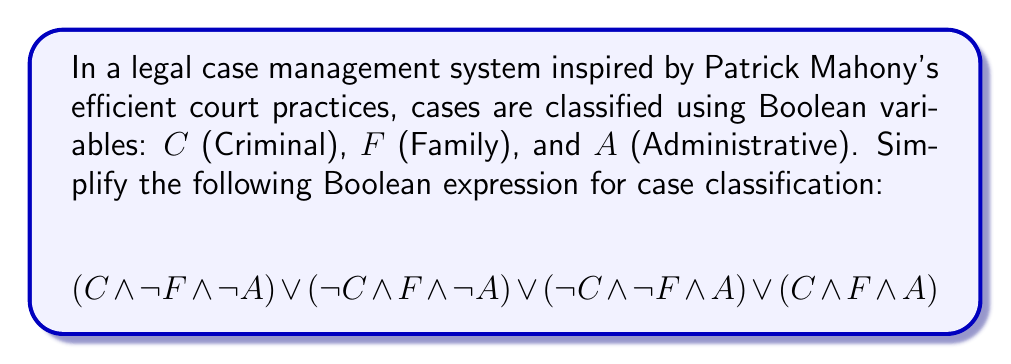Teach me how to tackle this problem. Let's simplify this Boolean expression step-by-step:

1) First, observe that the expression represents four mutually exclusive cases:
   - Criminal cases (not Family, not Administrative)
   - Family cases (not Criminal, not Administrative)
   - Administrative cases (not Criminal, not Family)
   - Cases that are simultaneously Criminal, Family, and Administrative

2) We can use the distributive law to factor out common terms:

   $$(C \land \lnot F \land \lnot A) \lor (\lnot C \land F \land \lnot A) \lor (\lnot C \land \lnot F \land A) \lor (C \land F \land A)$$
   $$= (\lnot A \land ((C \land \lnot F) \lor (\lnot C \land F))) \lor (A \land ((\lnot C \land \lnot F) \lor (C \land F)))$$

3) The terms $(C \land \lnot F) \lor (\lnot C \land F)$ and $(\lnot C \land \lnot F) \lor (C \land F)$ are both equivalent to the exclusive OR operation, $C \oplus F$:

   $$= (\lnot A \land (C \oplus F)) \lor (A \land (C \oplus F))$$

4) Now we can factor out the common $(C \oplus F)$ term:

   $$= (C \oplus F) \land (\lnot A \lor A)$$

5) $\lnot A \lor A$ is always true (law of excluded middle), so it can be removed:

   $$= C \oplus F$$

This simplified expression means that a case is classified if it's either Criminal or Family, but not both.
Answer: $C \oplus F$ 